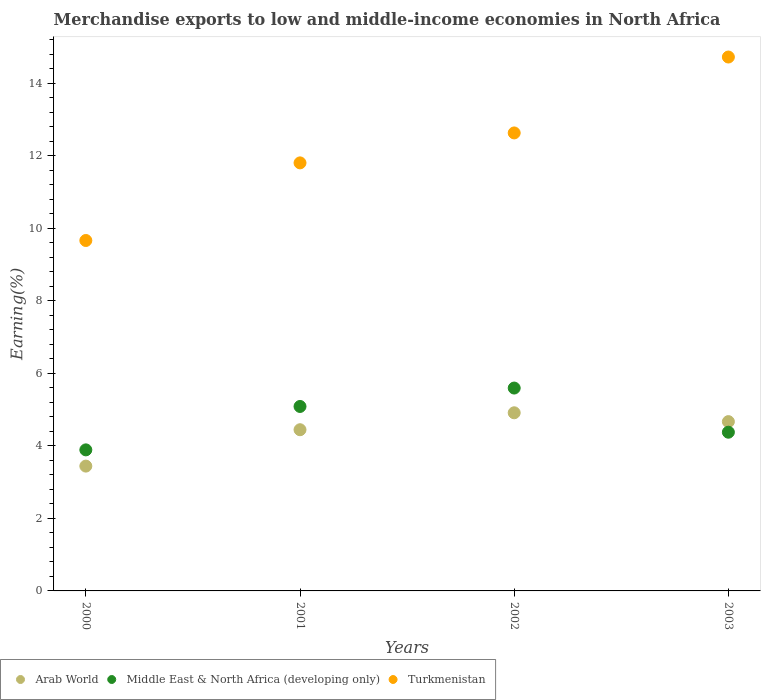How many different coloured dotlines are there?
Provide a succinct answer. 3. Is the number of dotlines equal to the number of legend labels?
Provide a short and direct response. Yes. What is the percentage of amount earned from merchandise exports in Middle East & North Africa (developing only) in 2001?
Provide a short and direct response. 5.09. Across all years, what is the maximum percentage of amount earned from merchandise exports in Middle East & North Africa (developing only)?
Ensure brevity in your answer.  5.59. Across all years, what is the minimum percentage of amount earned from merchandise exports in Middle East & North Africa (developing only)?
Ensure brevity in your answer.  3.89. In which year was the percentage of amount earned from merchandise exports in Middle East & North Africa (developing only) minimum?
Offer a terse response. 2000. What is the total percentage of amount earned from merchandise exports in Arab World in the graph?
Your response must be concise. 17.47. What is the difference between the percentage of amount earned from merchandise exports in Arab World in 2000 and that in 2003?
Provide a succinct answer. -1.23. What is the difference between the percentage of amount earned from merchandise exports in Arab World in 2003 and the percentage of amount earned from merchandise exports in Turkmenistan in 2000?
Offer a very short reply. -5. What is the average percentage of amount earned from merchandise exports in Arab World per year?
Provide a succinct answer. 4.37. In the year 2000, what is the difference between the percentage of amount earned from merchandise exports in Arab World and percentage of amount earned from merchandise exports in Middle East & North Africa (developing only)?
Your response must be concise. -0.45. In how many years, is the percentage of amount earned from merchandise exports in Middle East & North Africa (developing only) greater than 14.4 %?
Your response must be concise. 0. What is the ratio of the percentage of amount earned from merchandise exports in Arab World in 2000 to that in 2003?
Provide a short and direct response. 0.74. What is the difference between the highest and the second highest percentage of amount earned from merchandise exports in Arab World?
Offer a terse response. 0.24. What is the difference between the highest and the lowest percentage of amount earned from merchandise exports in Turkmenistan?
Make the answer very short. 5.06. In how many years, is the percentage of amount earned from merchandise exports in Middle East & North Africa (developing only) greater than the average percentage of amount earned from merchandise exports in Middle East & North Africa (developing only) taken over all years?
Your answer should be very brief. 2. Does the percentage of amount earned from merchandise exports in Arab World monotonically increase over the years?
Give a very brief answer. No. Is the percentage of amount earned from merchandise exports in Arab World strictly greater than the percentage of amount earned from merchandise exports in Middle East & North Africa (developing only) over the years?
Provide a succinct answer. No. Is the percentage of amount earned from merchandise exports in Arab World strictly less than the percentage of amount earned from merchandise exports in Turkmenistan over the years?
Your answer should be very brief. Yes. What is the difference between two consecutive major ticks on the Y-axis?
Ensure brevity in your answer.  2. Does the graph contain any zero values?
Your answer should be very brief. No. Where does the legend appear in the graph?
Ensure brevity in your answer.  Bottom left. How many legend labels are there?
Offer a terse response. 3. How are the legend labels stacked?
Provide a succinct answer. Horizontal. What is the title of the graph?
Offer a very short reply. Merchandise exports to low and middle-income economies in North Africa. What is the label or title of the Y-axis?
Your answer should be very brief. Earning(%). What is the Earning(%) of Arab World in 2000?
Provide a succinct answer. 3.44. What is the Earning(%) in Middle East & North Africa (developing only) in 2000?
Your response must be concise. 3.89. What is the Earning(%) of Turkmenistan in 2000?
Keep it short and to the point. 9.66. What is the Earning(%) of Arab World in 2001?
Offer a terse response. 4.45. What is the Earning(%) in Middle East & North Africa (developing only) in 2001?
Your answer should be compact. 5.09. What is the Earning(%) in Turkmenistan in 2001?
Make the answer very short. 11.8. What is the Earning(%) of Arab World in 2002?
Your response must be concise. 4.91. What is the Earning(%) of Middle East & North Africa (developing only) in 2002?
Give a very brief answer. 5.59. What is the Earning(%) in Turkmenistan in 2002?
Your answer should be very brief. 12.63. What is the Earning(%) in Arab World in 2003?
Your response must be concise. 4.67. What is the Earning(%) of Middle East & North Africa (developing only) in 2003?
Offer a very short reply. 4.38. What is the Earning(%) in Turkmenistan in 2003?
Your response must be concise. 14.72. Across all years, what is the maximum Earning(%) in Arab World?
Provide a short and direct response. 4.91. Across all years, what is the maximum Earning(%) in Middle East & North Africa (developing only)?
Give a very brief answer. 5.59. Across all years, what is the maximum Earning(%) of Turkmenistan?
Provide a short and direct response. 14.72. Across all years, what is the minimum Earning(%) of Arab World?
Make the answer very short. 3.44. Across all years, what is the minimum Earning(%) in Middle East & North Africa (developing only)?
Ensure brevity in your answer.  3.89. Across all years, what is the minimum Earning(%) of Turkmenistan?
Your answer should be very brief. 9.66. What is the total Earning(%) in Arab World in the graph?
Keep it short and to the point. 17.47. What is the total Earning(%) in Middle East & North Africa (developing only) in the graph?
Provide a succinct answer. 18.95. What is the total Earning(%) in Turkmenistan in the graph?
Provide a short and direct response. 48.82. What is the difference between the Earning(%) in Arab World in 2000 and that in 2001?
Provide a succinct answer. -1. What is the difference between the Earning(%) in Middle East & North Africa (developing only) in 2000 and that in 2001?
Keep it short and to the point. -1.2. What is the difference between the Earning(%) in Turkmenistan in 2000 and that in 2001?
Make the answer very short. -2.14. What is the difference between the Earning(%) in Arab World in 2000 and that in 2002?
Offer a very short reply. -1.47. What is the difference between the Earning(%) of Middle East & North Africa (developing only) in 2000 and that in 2002?
Offer a terse response. -1.7. What is the difference between the Earning(%) of Turkmenistan in 2000 and that in 2002?
Your answer should be very brief. -2.97. What is the difference between the Earning(%) of Arab World in 2000 and that in 2003?
Provide a succinct answer. -1.23. What is the difference between the Earning(%) of Middle East & North Africa (developing only) in 2000 and that in 2003?
Your response must be concise. -0.49. What is the difference between the Earning(%) of Turkmenistan in 2000 and that in 2003?
Offer a very short reply. -5.06. What is the difference between the Earning(%) in Arab World in 2001 and that in 2002?
Ensure brevity in your answer.  -0.47. What is the difference between the Earning(%) in Middle East & North Africa (developing only) in 2001 and that in 2002?
Provide a succinct answer. -0.51. What is the difference between the Earning(%) in Turkmenistan in 2001 and that in 2002?
Ensure brevity in your answer.  -0.83. What is the difference between the Earning(%) in Arab World in 2001 and that in 2003?
Your response must be concise. -0.22. What is the difference between the Earning(%) in Middle East & North Africa (developing only) in 2001 and that in 2003?
Give a very brief answer. 0.71. What is the difference between the Earning(%) of Turkmenistan in 2001 and that in 2003?
Provide a short and direct response. -2.92. What is the difference between the Earning(%) in Arab World in 2002 and that in 2003?
Offer a very short reply. 0.24. What is the difference between the Earning(%) of Middle East & North Africa (developing only) in 2002 and that in 2003?
Your answer should be compact. 1.22. What is the difference between the Earning(%) of Turkmenistan in 2002 and that in 2003?
Your answer should be very brief. -2.09. What is the difference between the Earning(%) of Arab World in 2000 and the Earning(%) of Middle East & North Africa (developing only) in 2001?
Give a very brief answer. -1.64. What is the difference between the Earning(%) in Arab World in 2000 and the Earning(%) in Turkmenistan in 2001?
Offer a very short reply. -8.36. What is the difference between the Earning(%) in Middle East & North Africa (developing only) in 2000 and the Earning(%) in Turkmenistan in 2001?
Give a very brief answer. -7.91. What is the difference between the Earning(%) in Arab World in 2000 and the Earning(%) in Middle East & North Africa (developing only) in 2002?
Keep it short and to the point. -2.15. What is the difference between the Earning(%) of Arab World in 2000 and the Earning(%) of Turkmenistan in 2002?
Your response must be concise. -9.19. What is the difference between the Earning(%) of Middle East & North Africa (developing only) in 2000 and the Earning(%) of Turkmenistan in 2002?
Your response must be concise. -8.74. What is the difference between the Earning(%) in Arab World in 2000 and the Earning(%) in Middle East & North Africa (developing only) in 2003?
Give a very brief answer. -0.93. What is the difference between the Earning(%) of Arab World in 2000 and the Earning(%) of Turkmenistan in 2003?
Make the answer very short. -11.28. What is the difference between the Earning(%) of Middle East & North Africa (developing only) in 2000 and the Earning(%) of Turkmenistan in 2003?
Your answer should be compact. -10.83. What is the difference between the Earning(%) in Arab World in 2001 and the Earning(%) in Middle East & North Africa (developing only) in 2002?
Your response must be concise. -1.15. What is the difference between the Earning(%) of Arab World in 2001 and the Earning(%) of Turkmenistan in 2002?
Make the answer very short. -8.18. What is the difference between the Earning(%) of Middle East & North Africa (developing only) in 2001 and the Earning(%) of Turkmenistan in 2002?
Give a very brief answer. -7.54. What is the difference between the Earning(%) in Arab World in 2001 and the Earning(%) in Middle East & North Africa (developing only) in 2003?
Offer a very short reply. 0.07. What is the difference between the Earning(%) of Arab World in 2001 and the Earning(%) of Turkmenistan in 2003?
Offer a very short reply. -10.28. What is the difference between the Earning(%) of Middle East & North Africa (developing only) in 2001 and the Earning(%) of Turkmenistan in 2003?
Keep it short and to the point. -9.64. What is the difference between the Earning(%) of Arab World in 2002 and the Earning(%) of Middle East & North Africa (developing only) in 2003?
Ensure brevity in your answer.  0.54. What is the difference between the Earning(%) in Arab World in 2002 and the Earning(%) in Turkmenistan in 2003?
Provide a short and direct response. -9.81. What is the difference between the Earning(%) of Middle East & North Africa (developing only) in 2002 and the Earning(%) of Turkmenistan in 2003?
Your response must be concise. -9.13. What is the average Earning(%) in Arab World per year?
Your answer should be very brief. 4.37. What is the average Earning(%) of Middle East & North Africa (developing only) per year?
Provide a succinct answer. 4.74. What is the average Earning(%) in Turkmenistan per year?
Offer a very short reply. 12.21. In the year 2000, what is the difference between the Earning(%) in Arab World and Earning(%) in Middle East & North Africa (developing only)?
Keep it short and to the point. -0.45. In the year 2000, what is the difference between the Earning(%) of Arab World and Earning(%) of Turkmenistan?
Offer a terse response. -6.22. In the year 2000, what is the difference between the Earning(%) in Middle East & North Africa (developing only) and Earning(%) in Turkmenistan?
Offer a terse response. -5.77. In the year 2001, what is the difference between the Earning(%) of Arab World and Earning(%) of Middle East & North Africa (developing only)?
Your answer should be very brief. -0.64. In the year 2001, what is the difference between the Earning(%) in Arab World and Earning(%) in Turkmenistan?
Keep it short and to the point. -7.36. In the year 2001, what is the difference between the Earning(%) of Middle East & North Africa (developing only) and Earning(%) of Turkmenistan?
Offer a terse response. -6.72. In the year 2002, what is the difference between the Earning(%) in Arab World and Earning(%) in Middle East & North Africa (developing only)?
Provide a succinct answer. -0.68. In the year 2002, what is the difference between the Earning(%) in Arab World and Earning(%) in Turkmenistan?
Your answer should be very brief. -7.72. In the year 2002, what is the difference between the Earning(%) in Middle East & North Africa (developing only) and Earning(%) in Turkmenistan?
Ensure brevity in your answer.  -7.04. In the year 2003, what is the difference between the Earning(%) of Arab World and Earning(%) of Middle East & North Africa (developing only)?
Your answer should be very brief. 0.29. In the year 2003, what is the difference between the Earning(%) in Arab World and Earning(%) in Turkmenistan?
Offer a terse response. -10.05. In the year 2003, what is the difference between the Earning(%) in Middle East & North Africa (developing only) and Earning(%) in Turkmenistan?
Your answer should be very brief. -10.35. What is the ratio of the Earning(%) in Arab World in 2000 to that in 2001?
Your answer should be compact. 0.77. What is the ratio of the Earning(%) of Middle East & North Africa (developing only) in 2000 to that in 2001?
Keep it short and to the point. 0.76. What is the ratio of the Earning(%) of Turkmenistan in 2000 to that in 2001?
Your answer should be very brief. 0.82. What is the ratio of the Earning(%) in Arab World in 2000 to that in 2002?
Make the answer very short. 0.7. What is the ratio of the Earning(%) in Middle East & North Africa (developing only) in 2000 to that in 2002?
Your response must be concise. 0.7. What is the ratio of the Earning(%) in Turkmenistan in 2000 to that in 2002?
Make the answer very short. 0.77. What is the ratio of the Earning(%) of Arab World in 2000 to that in 2003?
Your response must be concise. 0.74. What is the ratio of the Earning(%) in Middle East & North Africa (developing only) in 2000 to that in 2003?
Offer a very short reply. 0.89. What is the ratio of the Earning(%) of Turkmenistan in 2000 to that in 2003?
Your answer should be compact. 0.66. What is the ratio of the Earning(%) in Arab World in 2001 to that in 2002?
Offer a terse response. 0.9. What is the ratio of the Earning(%) in Middle East & North Africa (developing only) in 2001 to that in 2002?
Provide a short and direct response. 0.91. What is the ratio of the Earning(%) in Turkmenistan in 2001 to that in 2002?
Your answer should be very brief. 0.93. What is the ratio of the Earning(%) of Arab World in 2001 to that in 2003?
Provide a short and direct response. 0.95. What is the ratio of the Earning(%) of Middle East & North Africa (developing only) in 2001 to that in 2003?
Provide a short and direct response. 1.16. What is the ratio of the Earning(%) of Turkmenistan in 2001 to that in 2003?
Give a very brief answer. 0.8. What is the ratio of the Earning(%) of Arab World in 2002 to that in 2003?
Give a very brief answer. 1.05. What is the ratio of the Earning(%) of Middle East & North Africa (developing only) in 2002 to that in 2003?
Give a very brief answer. 1.28. What is the ratio of the Earning(%) in Turkmenistan in 2002 to that in 2003?
Your response must be concise. 0.86. What is the difference between the highest and the second highest Earning(%) in Arab World?
Your answer should be very brief. 0.24. What is the difference between the highest and the second highest Earning(%) of Middle East & North Africa (developing only)?
Provide a short and direct response. 0.51. What is the difference between the highest and the second highest Earning(%) of Turkmenistan?
Keep it short and to the point. 2.09. What is the difference between the highest and the lowest Earning(%) in Arab World?
Provide a short and direct response. 1.47. What is the difference between the highest and the lowest Earning(%) in Middle East & North Africa (developing only)?
Ensure brevity in your answer.  1.7. What is the difference between the highest and the lowest Earning(%) of Turkmenistan?
Offer a terse response. 5.06. 